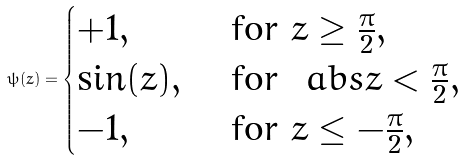Convert formula to latex. <formula><loc_0><loc_0><loc_500><loc_500>\psi ( z ) = \begin{cases} + 1 , & \text { for } z \geq \frac { \pi } { 2 } , \\ \sin ( z ) , & \text { for } \ a b s { z } < \frac { \pi } { 2 } , \\ - 1 , & \text { for } z \leq - \frac { \pi } { 2 } , \end{cases}</formula> 